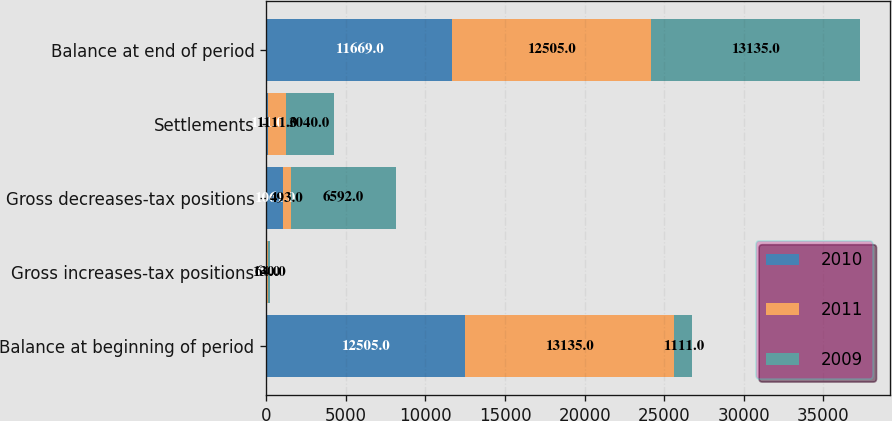Convert chart to OTSL. <chart><loc_0><loc_0><loc_500><loc_500><stacked_bar_chart><ecel><fcel>Balance at beginning of period<fcel>Gross increases-tax positions<fcel>Gross decreases-tax positions<fcel>Settlements<fcel>Balance at end of period<nl><fcel>2010<fcel>12505<fcel>40<fcel>1061<fcel>111<fcel>11669<nl><fcel>2011<fcel>13135<fcel>64<fcel>493<fcel>1111<fcel>12505<nl><fcel>2009<fcel>1111<fcel>130<fcel>6592<fcel>3040<fcel>13135<nl></chart> 